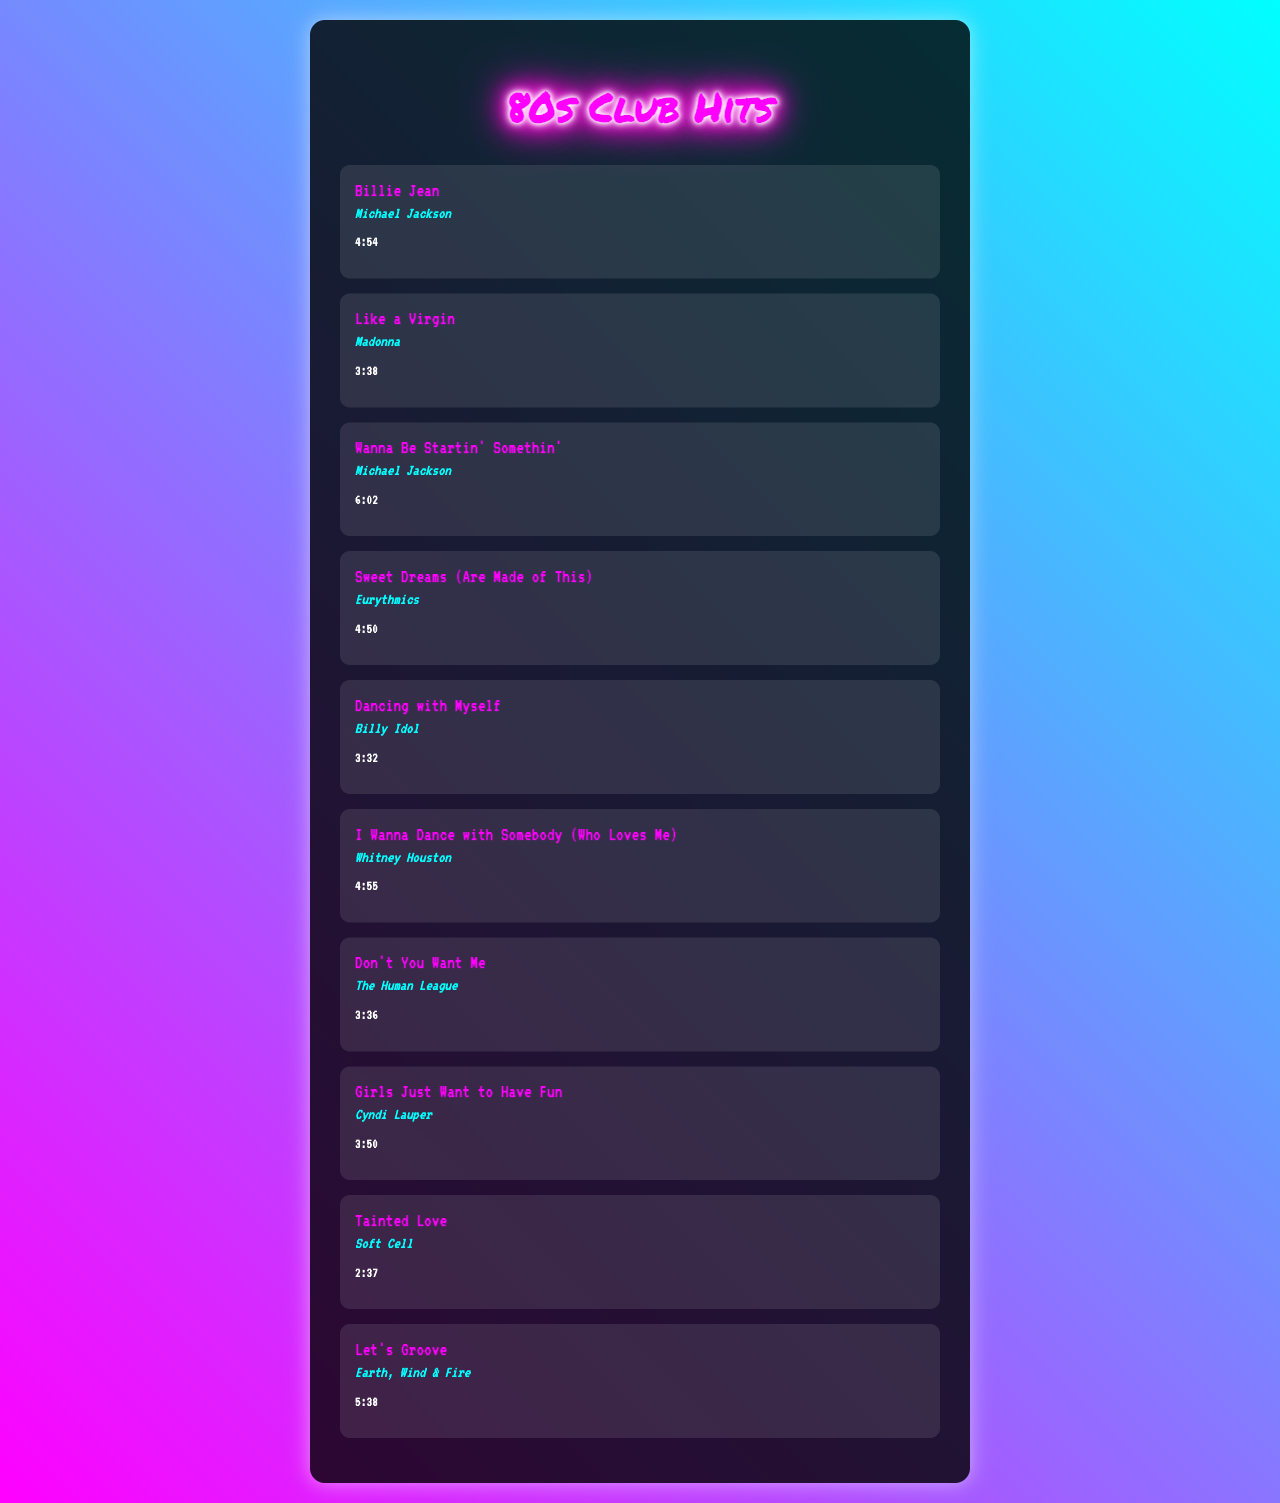What is the title of the first song? The first song listed in the playlist is "Billie Jean."
Answer: Billie Jean Who is the artist for "Like a Virgin"? The artist for "Like a Virgin" is Madonna.
Answer: Madonna What is the duration of "Sweet Dreams (Are Made of This)"? The duration of "Sweet Dreams (Are Made of This)" is specified as 4:50.
Answer: 4:50 Which song is by Billy Idol? The song by Billy Idol in the playlist is "Dancing with Myself."
Answer: Dancing with Myself What is the total number of songs in the playlist? The document lists a total of 10 songs in the playlist.
Answer: 10 Which two songs are performed by Michael Jackson? The songs performed by Michael Jackson are "Billie Jean" and "Wanna Be Startin' Somethin'."
Answer: Billie Jean, Wanna Be Startin' Somethin' What color is the background theme of the document? The background theme of the document features a gradient of pink and cyan colors.
Answer: Pink and cyan Which song has the shortest duration? The song with the shortest duration is "Tainted Love" at 2:37.
Answer: Tainted Love What genre can be associated with the songs in this document? The songs in this document are primarily associated with the pop genre.
Answer: Pop 